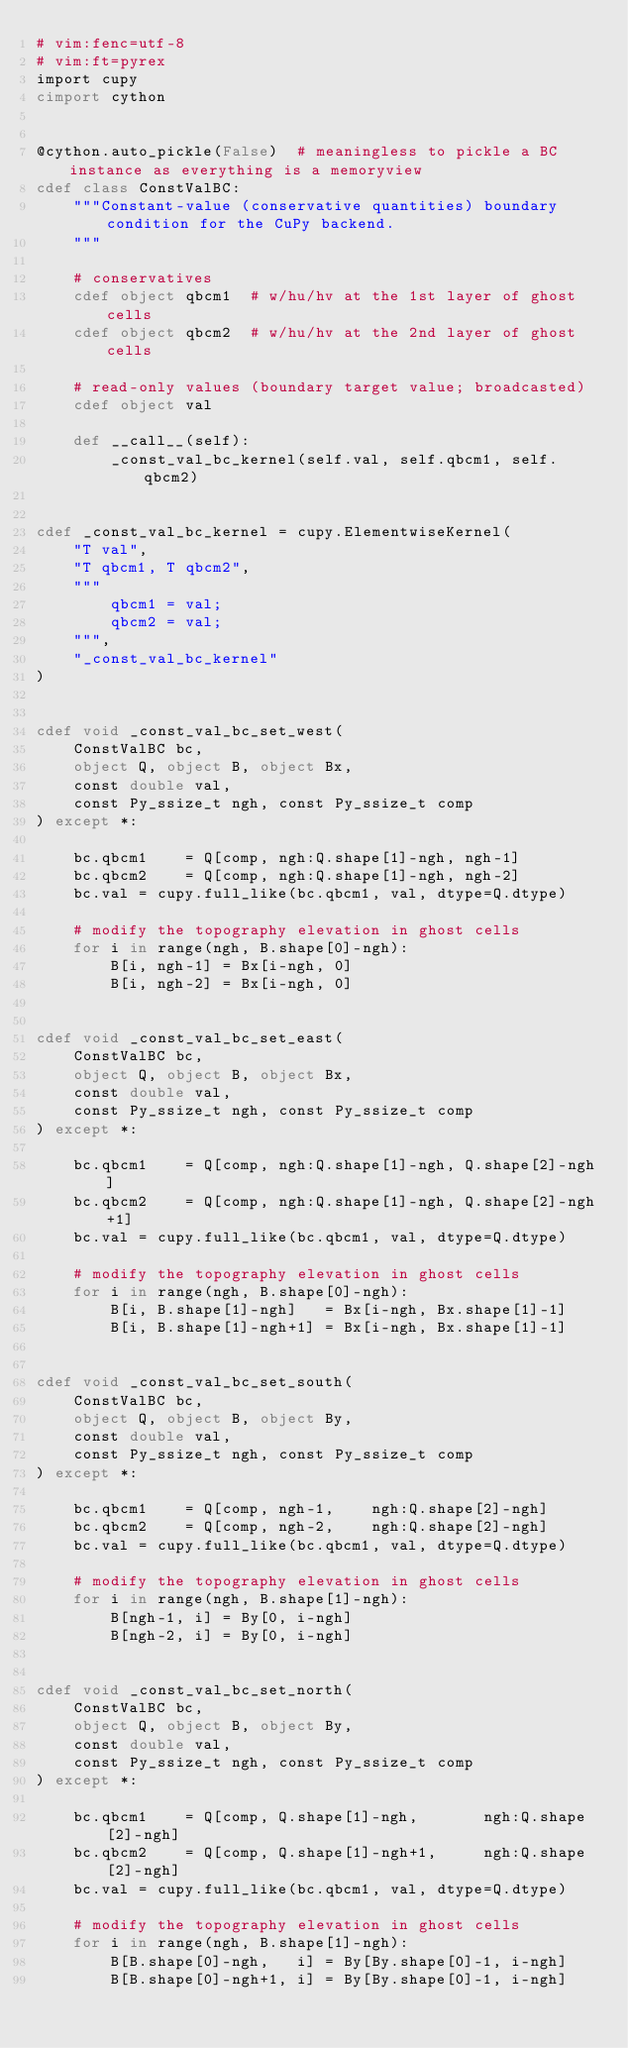<code> <loc_0><loc_0><loc_500><loc_500><_Cython_># vim:fenc=utf-8
# vim:ft=pyrex
import cupy
cimport cython


@cython.auto_pickle(False)  # meaningless to pickle a BC instance as everything is a memoryview
cdef class ConstValBC:
    """Constant-value (conservative quantities) boundary condition for the CuPy backend.
    """

    # conservatives
    cdef object qbcm1  # w/hu/hv at the 1st layer of ghost cells
    cdef object qbcm2  # w/hu/hv at the 2nd layer of ghost cells

    # read-only values (boundary target value; broadcasted)
    cdef object val

    def __call__(self):
        _const_val_bc_kernel(self.val, self.qbcm1, self.qbcm2)


cdef _const_val_bc_kernel = cupy.ElementwiseKernel(
    "T val",
    "T qbcm1, T qbcm2",
    """
        qbcm1 = val;
        qbcm2 = val;
    """,
    "_const_val_bc_kernel"
)


cdef void _const_val_bc_set_west(
    ConstValBC bc,
    object Q, object B, object Bx,
    const double val,
    const Py_ssize_t ngh, const Py_ssize_t comp
) except *:

    bc.qbcm1    = Q[comp, ngh:Q.shape[1]-ngh, ngh-1]
    bc.qbcm2    = Q[comp, ngh:Q.shape[1]-ngh, ngh-2]
    bc.val = cupy.full_like(bc.qbcm1, val, dtype=Q.dtype)

    # modify the topography elevation in ghost cells
    for i in range(ngh, B.shape[0]-ngh):
        B[i, ngh-1] = Bx[i-ngh, 0]
        B[i, ngh-2] = Bx[i-ngh, 0]


cdef void _const_val_bc_set_east(
    ConstValBC bc,
    object Q, object B, object Bx,
    const double val,
    const Py_ssize_t ngh, const Py_ssize_t comp
) except *:

    bc.qbcm1    = Q[comp, ngh:Q.shape[1]-ngh, Q.shape[2]-ngh]
    bc.qbcm2    = Q[comp, ngh:Q.shape[1]-ngh, Q.shape[2]-ngh+1]
    bc.val = cupy.full_like(bc.qbcm1, val, dtype=Q.dtype)

    # modify the topography elevation in ghost cells
    for i in range(ngh, B.shape[0]-ngh):
        B[i, B.shape[1]-ngh]   = Bx[i-ngh, Bx.shape[1]-1]
        B[i, B.shape[1]-ngh+1] = Bx[i-ngh, Bx.shape[1]-1]


cdef void _const_val_bc_set_south(
    ConstValBC bc,
    object Q, object B, object By,
    const double val,
    const Py_ssize_t ngh, const Py_ssize_t comp
) except *:

    bc.qbcm1    = Q[comp, ngh-1,    ngh:Q.shape[2]-ngh]
    bc.qbcm2    = Q[comp, ngh-2,    ngh:Q.shape[2]-ngh]
    bc.val = cupy.full_like(bc.qbcm1, val, dtype=Q.dtype)

    # modify the topography elevation in ghost cells
    for i in range(ngh, B.shape[1]-ngh):
        B[ngh-1, i] = By[0, i-ngh]
        B[ngh-2, i] = By[0, i-ngh]


cdef void _const_val_bc_set_north(
    ConstValBC bc,
    object Q, object B, object By,
    const double val,
    const Py_ssize_t ngh, const Py_ssize_t comp
) except *:

    bc.qbcm1    = Q[comp, Q.shape[1]-ngh,       ngh:Q.shape[2]-ngh]
    bc.qbcm2    = Q[comp, Q.shape[1]-ngh+1,     ngh:Q.shape[2]-ngh]
    bc.val = cupy.full_like(bc.qbcm1, val, dtype=Q.dtype)

    # modify the topography elevation in ghost cells
    for i in range(ngh, B.shape[1]-ngh):
        B[B.shape[0]-ngh,   i] = By[By.shape[0]-1, i-ngh]
        B[B.shape[0]-ngh+1, i] = By[By.shape[0]-1, i-ngh]

</code> 